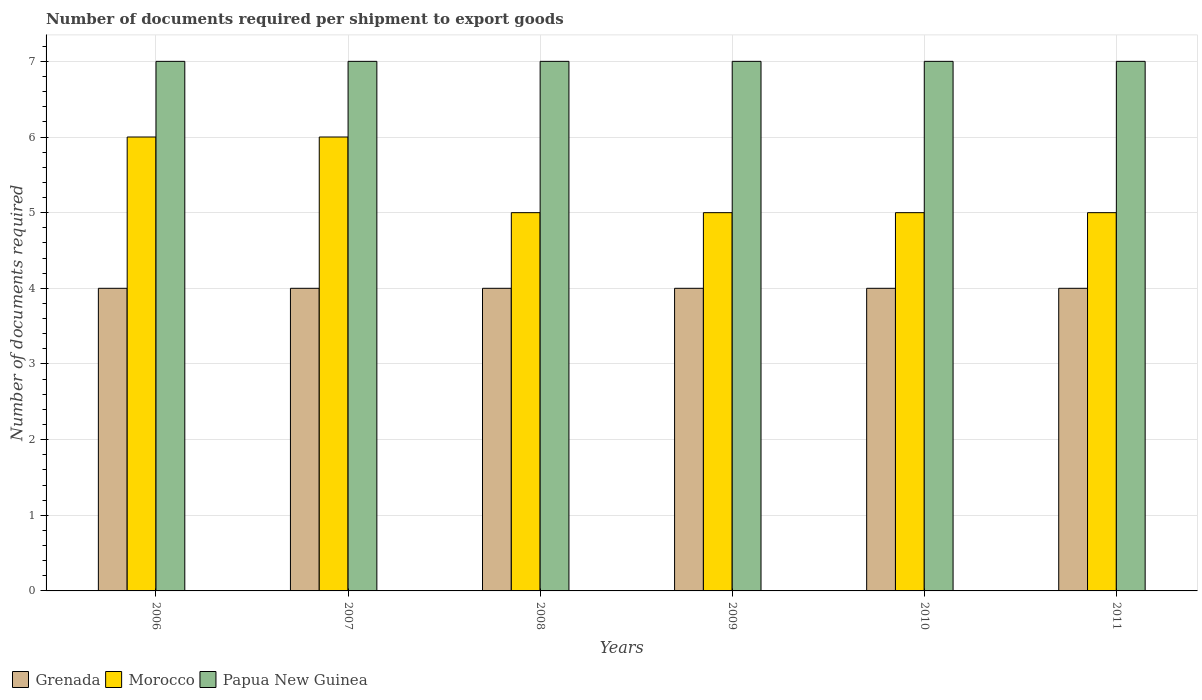How many different coloured bars are there?
Provide a short and direct response. 3. Are the number of bars on each tick of the X-axis equal?
Keep it short and to the point. Yes. How many bars are there on the 4th tick from the left?
Make the answer very short. 3. What is the number of documents required per shipment to export goods in Papua New Guinea in 2007?
Make the answer very short. 7. Across all years, what is the maximum number of documents required per shipment to export goods in Grenada?
Ensure brevity in your answer.  4. Across all years, what is the minimum number of documents required per shipment to export goods in Morocco?
Provide a short and direct response. 5. In which year was the number of documents required per shipment to export goods in Papua New Guinea maximum?
Your answer should be very brief. 2006. In which year was the number of documents required per shipment to export goods in Papua New Guinea minimum?
Provide a succinct answer. 2006. What is the total number of documents required per shipment to export goods in Grenada in the graph?
Your answer should be very brief. 24. What is the difference between the number of documents required per shipment to export goods in Morocco in 2011 and the number of documents required per shipment to export goods in Grenada in 2006?
Your answer should be very brief. 1. What is the average number of documents required per shipment to export goods in Morocco per year?
Your answer should be very brief. 5.33. In the year 2007, what is the difference between the number of documents required per shipment to export goods in Grenada and number of documents required per shipment to export goods in Papua New Guinea?
Provide a succinct answer. -3. Is the number of documents required per shipment to export goods in Papua New Guinea in 2009 less than that in 2010?
Give a very brief answer. No. Is the difference between the number of documents required per shipment to export goods in Grenada in 2010 and 2011 greater than the difference between the number of documents required per shipment to export goods in Papua New Guinea in 2010 and 2011?
Your answer should be compact. No. What is the difference between the highest and the lowest number of documents required per shipment to export goods in Papua New Guinea?
Give a very brief answer. 0. In how many years, is the number of documents required per shipment to export goods in Morocco greater than the average number of documents required per shipment to export goods in Morocco taken over all years?
Provide a succinct answer. 2. What does the 2nd bar from the left in 2007 represents?
Give a very brief answer. Morocco. What does the 3rd bar from the right in 2006 represents?
Offer a very short reply. Grenada. How many bars are there?
Ensure brevity in your answer.  18. Are all the bars in the graph horizontal?
Offer a terse response. No. What is the difference between two consecutive major ticks on the Y-axis?
Keep it short and to the point. 1. Are the values on the major ticks of Y-axis written in scientific E-notation?
Your answer should be compact. No. Does the graph contain any zero values?
Your answer should be very brief. No. Does the graph contain grids?
Offer a very short reply. Yes. Where does the legend appear in the graph?
Offer a terse response. Bottom left. How many legend labels are there?
Your answer should be very brief. 3. How are the legend labels stacked?
Give a very brief answer. Horizontal. What is the title of the graph?
Give a very brief answer. Number of documents required per shipment to export goods. Does "Tuvalu" appear as one of the legend labels in the graph?
Make the answer very short. No. What is the label or title of the X-axis?
Provide a short and direct response. Years. What is the label or title of the Y-axis?
Your answer should be very brief. Number of documents required. What is the Number of documents required of Papua New Guinea in 2006?
Your response must be concise. 7. What is the Number of documents required in Grenada in 2007?
Give a very brief answer. 4. What is the Number of documents required of Morocco in 2007?
Offer a terse response. 6. What is the Number of documents required of Papua New Guinea in 2007?
Give a very brief answer. 7. What is the Number of documents required of Grenada in 2008?
Your response must be concise. 4. What is the Number of documents required in Papua New Guinea in 2008?
Offer a terse response. 7. What is the Number of documents required of Morocco in 2009?
Keep it short and to the point. 5. What is the Number of documents required of Morocco in 2011?
Your answer should be very brief. 5. Across all years, what is the maximum Number of documents required in Grenada?
Keep it short and to the point. 4. Across all years, what is the maximum Number of documents required of Morocco?
Offer a terse response. 6. What is the total Number of documents required of Grenada in the graph?
Keep it short and to the point. 24. What is the total Number of documents required of Morocco in the graph?
Your answer should be compact. 32. What is the difference between the Number of documents required in Papua New Guinea in 2006 and that in 2007?
Give a very brief answer. 0. What is the difference between the Number of documents required of Grenada in 2006 and that in 2008?
Give a very brief answer. 0. What is the difference between the Number of documents required of Grenada in 2006 and that in 2009?
Give a very brief answer. 0. What is the difference between the Number of documents required of Grenada in 2006 and that in 2010?
Make the answer very short. 0. What is the difference between the Number of documents required of Morocco in 2006 and that in 2010?
Your answer should be compact. 1. What is the difference between the Number of documents required of Grenada in 2006 and that in 2011?
Keep it short and to the point. 0. What is the difference between the Number of documents required in Morocco in 2006 and that in 2011?
Keep it short and to the point. 1. What is the difference between the Number of documents required in Morocco in 2007 and that in 2008?
Provide a short and direct response. 1. What is the difference between the Number of documents required of Papua New Guinea in 2007 and that in 2009?
Provide a succinct answer. 0. What is the difference between the Number of documents required of Papua New Guinea in 2007 and that in 2010?
Ensure brevity in your answer.  0. What is the difference between the Number of documents required of Morocco in 2007 and that in 2011?
Keep it short and to the point. 1. What is the difference between the Number of documents required in Papua New Guinea in 2008 and that in 2009?
Provide a short and direct response. 0. What is the difference between the Number of documents required in Morocco in 2008 and that in 2010?
Make the answer very short. 0. What is the difference between the Number of documents required in Grenada in 2008 and that in 2011?
Make the answer very short. 0. What is the difference between the Number of documents required in Papua New Guinea in 2008 and that in 2011?
Your answer should be compact. 0. What is the difference between the Number of documents required in Morocco in 2009 and that in 2010?
Provide a short and direct response. 0. What is the difference between the Number of documents required of Papua New Guinea in 2009 and that in 2010?
Ensure brevity in your answer.  0. What is the difference between the Number of documents required in Papua New Guinea in 2009 and that in 2011?
Make the answer very short. 0. What is the difference between the Number of documents required in Morocco in 2010 and that in 2011?
Keep it short and to the point. 0. What is the difference between the Number of documents required of Papua New Guinea in 2010 and that in 2011?
Your answer should be compact. 0. What is the difference between the Number of documents required of Grenada in 2006 and the Number of documents required of Papua New Guinea in 2007?
Ensure brevity in your answer.  -3. What is the difference between the Number of documents required of Grenada in 2006 and the Number of documents required of Papua New Guinea in 2008?
Ensure brevity in your answer.  -3. What is the difference between the Number of documents required of Morocco in 2006 and the Number of documents required of Papua New Guinea in 2008?
Offer a terse response. -1. What is the difference between the Number of documents required of Grenada in 2006 and the Number of documents required of Morocco in 2009?
Your answer should be very brief. -1. What is the difference between the Number of documents required of Grenada in 2006 and the Number of documents required of Papua New Guinea in 2009?
Make the answer very short. -3. What is the difference between the Number of documents required of Grenada in 2006 and the Number of documents required of Morocco in 2010?
Give a very brief answer. -1. What is the difference between the Number of documents required in Grenada in 2006 and the Number of documents required in Papua New Guinea in 2010?
Your answer should be very brief. -3. What is the difference between the Number of documents required of Morocco in 2006 and the Number of documents required of Papua New Guinea in 2010?
Your response must be concise. -1. What is the difference between the Number of documents required of Grenada in 2006 and the Number of documents required of Morocco in 2011?
Make the answer very short. -1. What is the difference between the Number of documents required of Grenada in 2006 and the Number of documents required of Papua New Guinea in 2011?
Provide a succinct answer. -3. What is the difference between the Number of documents required of Morocco in 2006 and the Number of documents required of Papua New Guinea in 2011?
Your response must be concise. -1. What is the difference between the Number of documents required of Grenada in 2007 and the Number of documents required of Morocco in 2009?
Give a very brief answer. -1. What is the difference between the Number of documents required of Grenada in 2007 and the Number of documents required of Papua New Guinea in 2009?
Your answer should be compact. -3. What is the difference between the Number of documents required in Grenada in 2007 and the Number of documents required in Morocco in 2010?
Your response must be concise. -1. What is the difference between the Number of documents required of Grenada in 2007 and the Number of documents required of Papua New Guinea in 2010?
Ensure brevity in your answer.  -3. What is the difference between the Number of documents required of Morocco in 2007 and the Number of documents required of Papua New Guinea in 2010?
Offer a terse response. -1. What is the difference between the Number of documents required in Grenada in 2007 and the Number of documents required in Morocco in 2011?
Provide a succinct answer. -1. What is the difference between the Number of documents required of Grenada in 2007 and the Number of documents required of Papua New Guinea in 2011?
Your answer should be compact. -3. What is the difference between the Number of documents required in Morocco in 2007 and the Number of documents required in Papua New Guinea in 2011?
Provide a short and direct response. -1. What is the difference between the Number of documents required of Grenada in 2008 and the Number of documents required of Papua New Guinea in 2009?
Give a very brief answer. -3. What is the difference between the Number of documents required of Grenada in 2008 and the Number of documents required of Morocco in 2010?
Keep it short and to the point. -1. What is the difference between the Number of documents required in Grenada in 2009 and the Number of documents required in Morocco in 2010?
Offer a terse response. -1. What is the difference between the Number of documents required in Grenada in 2009 and the Number of documents required in Morocco in 2011?
Keep it short and to the point. -1. What is the difference between the Number of documents required of Grenada in 2010 and the Number of documents required of Morocco in 2011?
Your answer should be compact. -1. What is the difference between the Number of documents required in Morocco in 2010 and the Number of documents required in Papua New Guinea in 2011?
Your response must be concise. -2. What is the average Number of documents required in Grenada per year?
Your answer should be compact. 4. What is the average Number of documents required of Morocco per year?
Keep it short and to the point. 5.33. What is the average Number of documents required in Papua New Guinea per year?
Ensure brevity in your answer.  7. In the year 2006, what is the difference between the Number of documents required of Grenada and Number of documents required of Morocco?
Your answer should be compact. -2. In the year 2006, what is the difference between the Number of documents required in Grenada and Number of documents required in Papua New Guinea?
Ensure brevity in your answer.  -3. In the year 2008, what is the difference between the Number of documents required in Morocco and Number of documents required in Papua New Guinea?
Your answer should be compact. -2. In the year 2009, what is the difference between the Number of documents required in Grenada and Number of documents required in Papua New Guinea?
Make the answer very short. -3. In the year 2009, what is the difference between the Number of documents required in Morocco and Number of documents required in Papua New Guinea?
Offer a very short reply. -2. In the year 2010, what is the difference between the Number of documents required of Grenada and Number of documents required of Papua New Guinea?
Make the answer very short. -3. In the year 2011, what is the difference between the Number of documents required in Morocco and Number of documents required in Papua New Guinea?
Provide a succinct answer. -2. What is the ratio of the Number of documents required of Morocco in 2006 to that in 2007?
Offer a terse response. 1. What is the ratio of the Number of documents required of Papua New Guinea in 2006 to that in 2007?
Your answer should be compact. 1. What is the ratio of the Number of documents required in Papua New Guinea in 2006 to that in 2008?
Provide a short and direct response. 1. What is the ratio of the Number of documents required in Morocco in 2006 to that in 2009?
Your answer should be compact. 1.2. What is the ratio of the Number of documents required in Papua New Guinea in 2006 to that in 2009?
Make the answer very short. 1. What is the ratio of the Number of documents required of Grenada in 2006 to that in 2010?
Your response must be concise. 1. What is the ratio of the Number of documents required in Papua New Guinea in 2006 to that in 2010?
Make the answer very short. 1. What is the ratio of the Number of documents required of Papua New Guinea in 2006 to that in 2011?
Make the answer very short. 1. What is the ratio of the Number of documents required of Grenada in 2007 to that in 2008?
Give a very brief answer. 1. What is the ratio of the Number of documents required of Grenada in 2007 to that in 2010?
Your answer should be compact. 1. What is the ratio of the Number of documents required in Morocco in 2007 to that in 2010?
Provide a short and direct response. 1.2. What is the ratio of the Number of documents required of Papua New Guinea in 2007 to that in 2010?
Give a very brief answer. 1. What is the ratio of the Number of documents required in Morocco in 2007 to that in 2011?
Provide a succinct answer. 1.2. What is the ratio of the Number of documents required of Papua New Guinea in 2007 to that in 2011?
Keep it short and to the point. 1. What is the ratio of the Number of documents required in Morocco in 2008 to that in 2009?
Keep it short and to the point. 1. What is the ratio of the Number of documents required in Grenada in 2008 to that in 2010?
Offer a very short reply. 1. What is the ratio of the Number of documents required of Morocco in 2008 to that in 2010?
Your answer should be very brief. 1. What is the ratio of the Number of documents required in Papua New Guinea in 2008 to that in 2010?
Provide a short and direct response. 1. What is the ratio of the Number of documents required of Grenada in 2009 to that in 2010?
Offer a terse response. 1. What is the ratio of the Number of documents required in Papua New Guinea in 2009 to that in 2010?
Ensure brevity in your answer.  1. What is the ratio of the Number of documents required in Grenada in 2009 to that in 2011?
Provide a succinct answer. 1. What is the ratio of the Number of documents required in Morocco in 2009 to that in 2011?
Provide a succinct answer. 1. What is the ratio of the Number of documents required of Papua New Guinea in 2010 to that in 2011?
Keep it short and to the point. 1. What is the difference between the highest and the second highest Number of documents required of Morocco?
Ensure brevity in your answer.  0. What is the difference between the highest and the lowest Number of documents required of Grenada?
Keep it short and to the point. 0. What is the difference between the highest and the lowest Number of documents required of Morocco?
Make the answer very short. 1. What is the difference between the highest and the lowest Number of documents required in Papua New Guinea?
Provide a short and direct response. 0. 